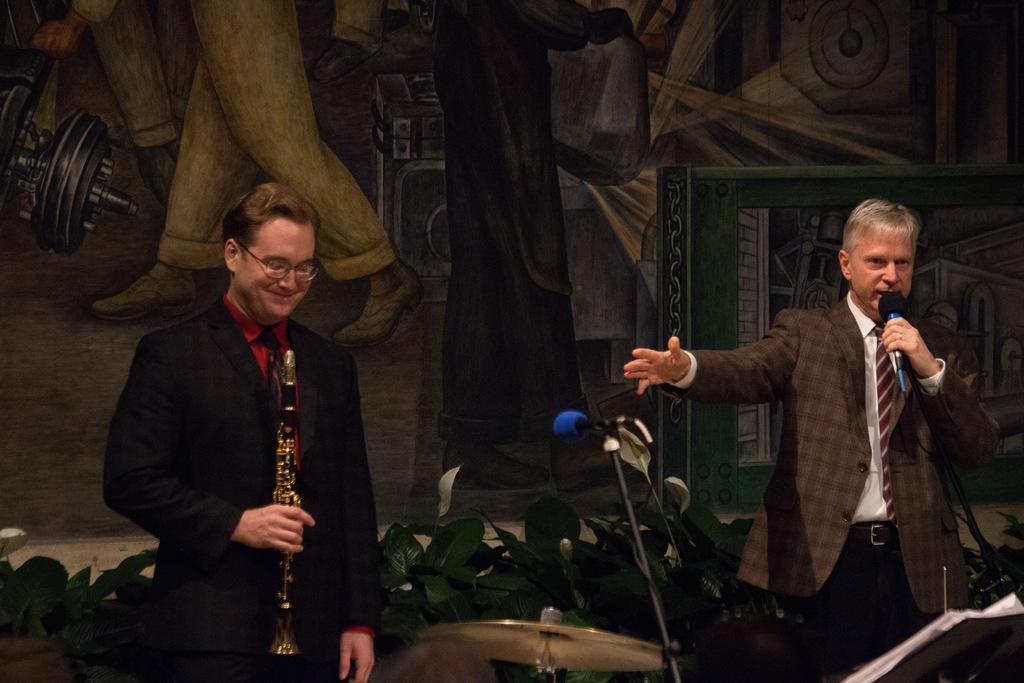Can you describe this image briefly? He is a man standing on the left side and he is holding a saxophone in his right hand and he is smiling. He is a man on the right side. He is holding a microphone in his left hand and he is speaking. This is a microphone which is in the center. 